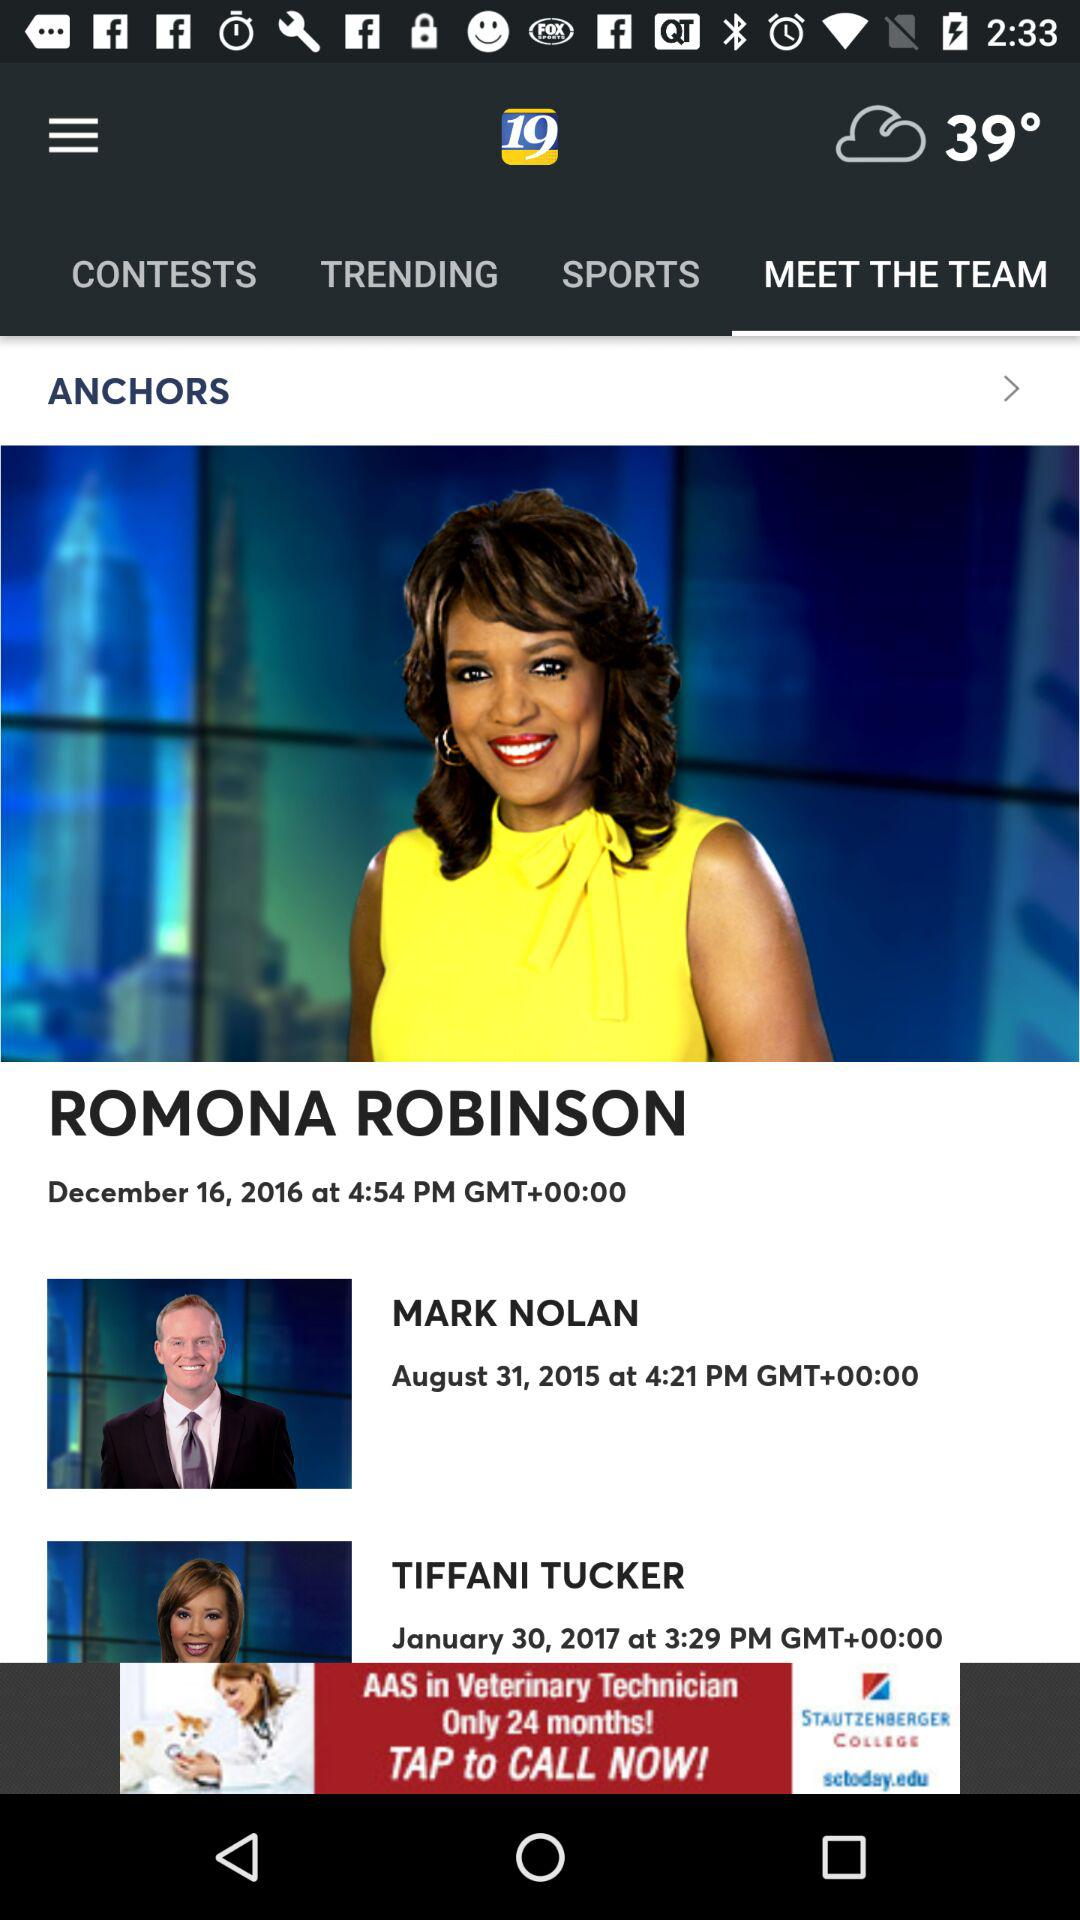When was the show hosted by anchor Romona Robinson posted? The show was posted on December 16, 2016 at 4:54 PM GMT+00:00. 